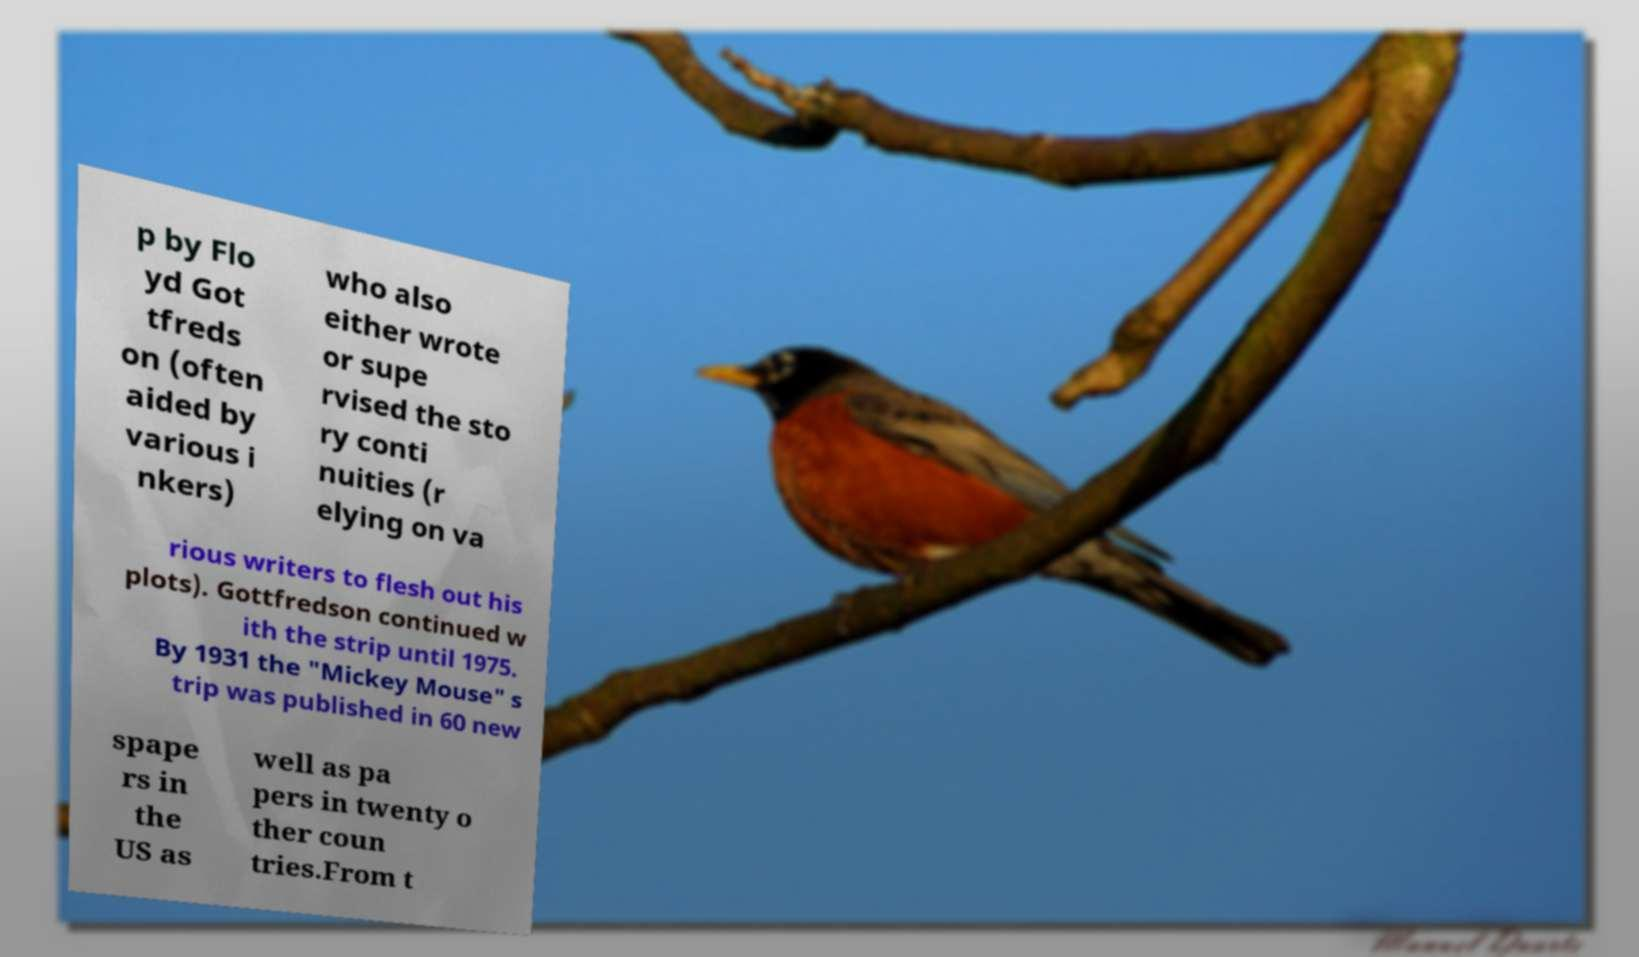Please identify and transcribe the text found in this image. p by Flo yd Got tfreds on (often aided by various i nkers) who also either wrote or supe rvised the sto ry conti nuities (r elying on va rious writers to flesh out his plots). Gottfredson continued w ith the strip until 1975. By 1931 the "Mickey Mouse" s trip was published in 60 new spape rs in the US as well as pa pers in twenty o ther coun tries.From t 